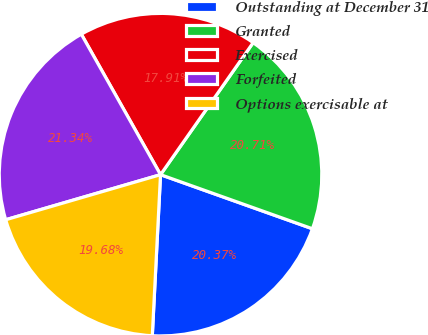Convert chart. <chart><loc_0><loc_0><loc_500><loc_500><pie_chart><fcel>Outstanding at December 31<fcel>Granted<fcel>Exercised<fcel>Forfeited<fcel>Options exercisable at<nl><fcel>20.37%<fcel>20.71%<fcel>17.91%<fcel>21.34%<fcel>19.68%<nl></chart> 